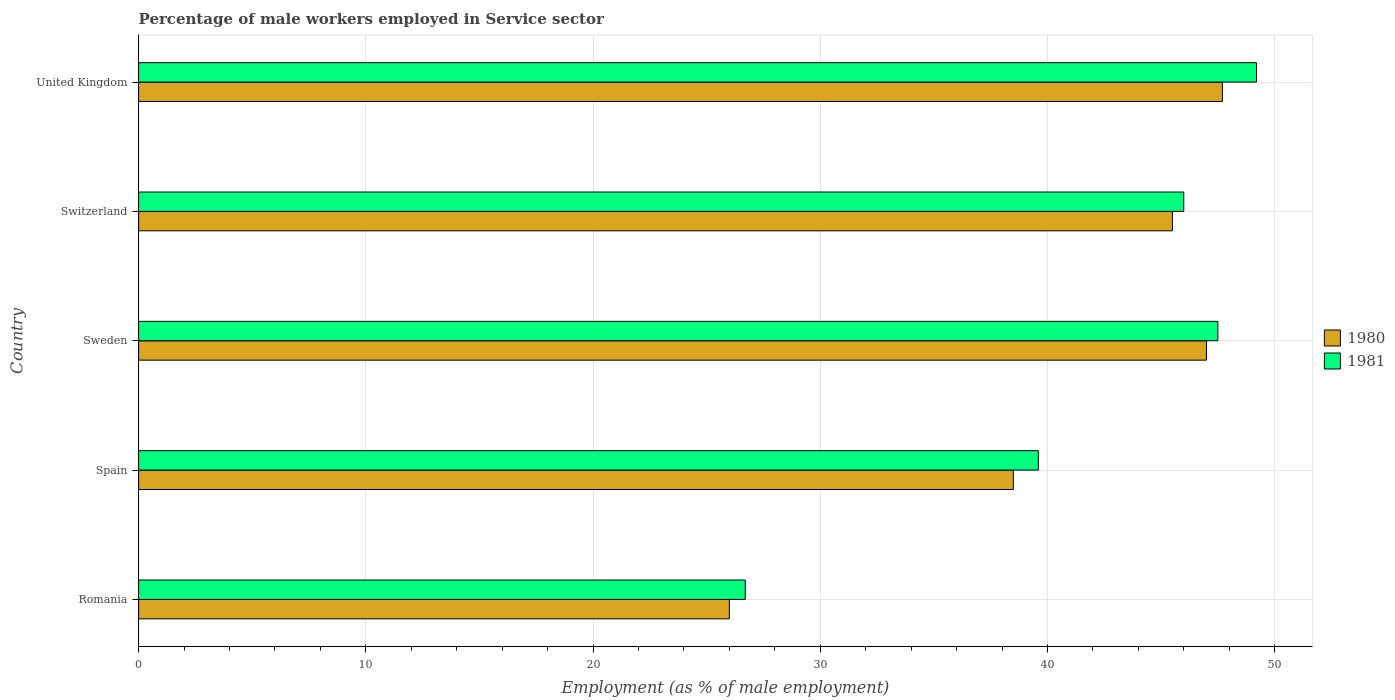How many different coloured bars are there?
Your answer should be compact. 2. Are the number of bars per tick equal to the number of legend labels?
Offer a terse response. Yes. Are the number of bars on each tick of the Y-axis equal?
Provide a succinct answer. Yes. What is the label of the 4th group of bars from the top?
Provide a succinct answer. Spain. In how many cases, is the number of bars for a given country not equal to the number of legend labels?
Your response must be concise. 0. What is the percentage of male workers employed in Service sector in 1980 in United Kingdom?
Provide a succinct answer. 47.7. Across all countries, what is the maximum percentage of male workers employed in Service sector in 1981?
Ensure brevity in your answer.  49.2. Across all countries, what is the minimum percentage of male workers employed in Service sector in 1980?
Your answer should be very brief. 26. In which country was the percentage of male workers employed in Service sector in 1981 maximum?
Provide a short and direct response. United Kingdom. In which country was the percentage of male workers employed in Service sector in 1981 minimum?
Ensure brevity in your answer.  Romania. What is the total percentage of male workers employed in Service sector in 1981 in the graph?
Offer a terse response. 209. What is the difference between the percentage of male workers employed in Service sector in 1980 in Romania and that in Spain?
Make the answer very short. -12.5. What is the difference between the percentage of male workers employed in Service sector in 1980 in Spain and the percentage of male workers employed in Service sector in 1981 in Romania?
Your answer should be compact. 11.8. What is the average percentage of male workers employed in Service sector in 1981 per country?
Ensure brevity in your answer.  41.8. What is the difference between the percentage of male workers employed in Service sector in 1981 and percentage of male workers employed in Service sector in 1980 in Sweden?
Provide a short and direct response. 0.5. In how many countries, is the percentage of male workers employed in Service sector in 1981 greater than 32 %?
Provide a succinct answer. 4. What is the ratio of the percentage of male workers employed in Service sector in 1981 in Romania to that in Spain?
Provide a short and direct response. 0.67. Is the difference between the percentage of male workers employed in Service sector in 1981 in Sweden and Switzerland greater than the difference between the percentage of male workers employed in Service sector in 1980 in Sweden and Switzerland?
Provide a short and direct response. No. What is the difference between the highest and the second highest percentage of male workers employed in Service sector in 1980?
Give a very brief answer. 0.7. What is the difference between the highest and the lowest percentage of male workers employed in Service sector in 1981?
Your answer should be compact. 22.5. Is the sum of the percentage of male workers employed in Service sector in 1980 in Sweden and Switzerland greater than the maximum percentage of male workers employed in Service sector in 1981 across all countries?
Make the answer very short. Yes. How many bars are there?
Offer a terse response. 10. Are all the bars in the graph horizontal?
Make the answer very short. Yes. Are the values on the major ticks of X-axis written in scientific E-notation?
Make the answer very short. No. How many legend labels are there?
Keep it short and to the point. 2. How are the legend labels stacked?
Your response must be concise. Vertical. What is the title of the graph?
Offer a terse response. Percentage of male workers employed in Service sector. Does "1964" appear as one of the legend labels in the graph?
Offer a terse response. No. What is the label or title of the X-axis?
Your response must be concise. Employment (as % of male employment). What is the Employment (as % of male employment) in 1980 in Romania?
Your answer should be compact. 26. What is the Employment (as % of male employment) in 1981 in Romania?
Make the answer very short. 26.7. What is the Employment (as % of male employment) in 1980 in Spain?
Keep it short and to the point. 38.5. What is the Employment (as % of male employment) in 1981 in Spain?
Keep it short and to the point. 39.6. What is the Employment (as % of male employment) of 1981 in Sweden?
Keep it short and to the point. 47.5. What is the Employment (as % of male employment) in 1980 in Switzerland?
Offer a terse response. 45.5. What is the Employment (as % of male employment) of 1981 in Switzerland?
Provide a short and direct response. 46. What is the Employment (as % of male employment) of 1980 in United Kingdom?
Your answer should be very brief. 47.7. What is the Employment (as % of male employment) in 1981 in United Kingdom?
Your response must be concise. 49.2. Across all countries, what is the maximum Employment (as % of male employment) in 1980?
Provide a short and direct response. 47.7. Across all countries, what is the maximum Employment (as % of male employment) in 1981?
Your answer should be compact. 49.2. Across all countries, what is the minimum Employment (as % of male employment) in 1981?
Make the answer very short. 26.7. What is the total Employment (as % of male employment) of 1980 in the graph?
Make the answer very short. 204.7. What is the total Employment (as % of male employment) in 1981 in the graph?
Provide a succinct answer. 209. What is the difference between the Employment (as % of male employment) in 1981 in Romania and that in Sweden?
Your response must be concise. -20.8. What is the difference between the Employment (as % of male employment) of 1980 in Romania and that in Switzerland?
Offer a terse response. -19.5. What is the difference between the Employment (as % of male employment) of 1981 in Romania and that in Switzerland?
Your response must be concise. -19.3. What is the difference between the Employment (as % of male employment) of 1980 in Romania and that in United Kingdom?
Your answer should be very brief. -21.7. What is the difference between the Employment (as % of male employment) in 1981 in Romania and that in United Kingdom?
Ensure brevity in your answer.  -22.5. What is the difference between the Employment (as % of male employment) in 1980 in Spain and that in Switzerland?
Offer a terse response. -7. What is the difference between the Employment (as % of male employment) in 1980 in Spain and that in United Kingdom?
Your response must be concise. -9.2. What is the difference between the Employment (as % of male employment) in 1981 in Spain and that in United Kingdom?
Keep it short and to the point. -9.6. What is the difference between the Employment (as % of male employment) in 1981 in Sweden and that in Switzerland?
Offer a terse response. 1.5. What is the difference between the Employment (as % of male employment) in 1980 in Sweden and that in United Kingdom?
Provide a short and direct response. -0.7. What is the difference between the Employment (as % of male employment) of 1981 in Sweden and that in United Kingdom?
Offer a very short reply. -1.7. What is the difference between the Employment (as % of male employment) of 1980 in Switzerland and that in United Kingdom?
Your response must be concise. -2.2. What is the difference between the Employment (as % of male employment) in 1980 in Romania and the Employment (as % of male employment) in 1981 in Spain?
Your response must be concise. -13.6. What is the difference between the Employment (as % of male employment) in 1980 in Romania and the Employment (as % of male employment) in 1981 in Sweden?
Make the answer very short. -21.5. What is the difference between the Employment (as % of male employment) in 1980 in Romania and the Employment (as % of male employment) in 1981 in United Kingdom?
Make the answer very short. -23.2. What is the difference between the Employment (as % of male employment) of 1980 in Sweden and the Employment (as % of male employment) of 1981 in United Kingdom?
Ensure brevity in your answer.  -2.2. What is the difference between the Employment (as % of male employment) in 1980 in Switzerland and the Employment (as % of male employment) in 1981 in United Kingdom?
Give a very brief answer. -3.7. What is the average Employment (as % of male employment) of 1980 per country?
Your response must be concise. 40.94. What is the average Employment (as % of male employment) of 1981 per country?
Provide a succinct answer. 41.8. What is the difference between the Employment (as % of male employment) of 1980 and Employment (as % of male employment) of 1981 in Spain?
Your response must be concise. -1.1. What is the difference between the Employment (as % of male employment) of 1980 and Employment (as % of male employment) of 1981 in United Kingdom?
Your answer should be very brief. -1.5. What is the ratio of the Employment (as % of male employment) in 1980 in Romania to that in Spain?
Provide a short and direct response. 0.68. What is the ratio of the Employment (as % of male employment) in 1981 in Romania to that in Spain?
Your answer should be very brief. 0.67. What is the ratio of the Employment (as % of male employment) of 1980 in Romania to that in Sweden?
Ensure brevity in your answer.  0.55. What is the ratio of the Employment (as % of male employment) of 1981 in Romania to that in Sweden?
Provide a succinct answer. 0.56. What is the ratio of the Employment (as % of male employment) of 1981 in Romania to that in Switzerland?
Provide a short and direct response. 0.58. What is the ratio of the Employment (as % of male employment) of 1980 in Romania to that in United Kingdom?
Your answer should be compact. 0.55. What is the ratio of the Employment (as % of male employment) of 1981 in Romania to that in United Kingdom?
Offer a terse response. 0.54. What is the ratio of the Employment (as % of male employment) of 1980 in Spain to that in Sweden?
Provide a succinct answer. 0.82. What is the ratio of the Employment (as % of male employment) of 1981 in Spain to that in Sweden?
Keep it short and to the point. 0.83. What is the ratio of the Employment (as % of male employment) of 1980 in Spain to that in Switzerland?
Your response must be concise. 0.85. What is the ratio of the Employment (as % of male employment) of 1981 in Spain to that in Switzerland?
Your answer should be very brief. 0.86. What is the ratio of the Employment (as % of male employment) of 1980 in Spain to that in United Kingdom?
Give a very brief answer. 0.81. What is the ratio of the Employment (as % of male employment) of 1981 in Spain to that in United Kingdom?
Provide a succinct answer. 0.8. What is the ratio of the Employment (as % of male employment) of 1980 in Sweden to that in Switzerland?
Provide a short and direct response. 1.03. What is the ratio of the Employment (as % of male employment) of 1981 in Sweden to that in Switzerland?
Offer a very short reply. 1.03. What is the ratio of the Employment (as % of male employment) in 1980 in Sweden to that in United Kingdom?
Give a very brief answer. 0.99. What is the ratio of the Employment (as % of male employment) in 1981 in Sweden to that in United Kingdom?
Give a very brief answer. 0.97. What is the ratio of the Employment (as % of male employment) in 1980 in Switzerland to that in United Kingdom?
Provide a short and direct response. 0.95. What is the ratio of the Employment (as % of male employment) in 1981 in Switzerland to that in United Kingdom?
Ensure brevity in your answer.  0.94. What is the difference between the highest and the lowest Employment (as % of male employment) in 1980?
Your response must be concise. 21.7. What is the difference between the highest and the lowest Employment (as % of male employment) in 1981?
Ensure brevity in your answer.  22.5. 